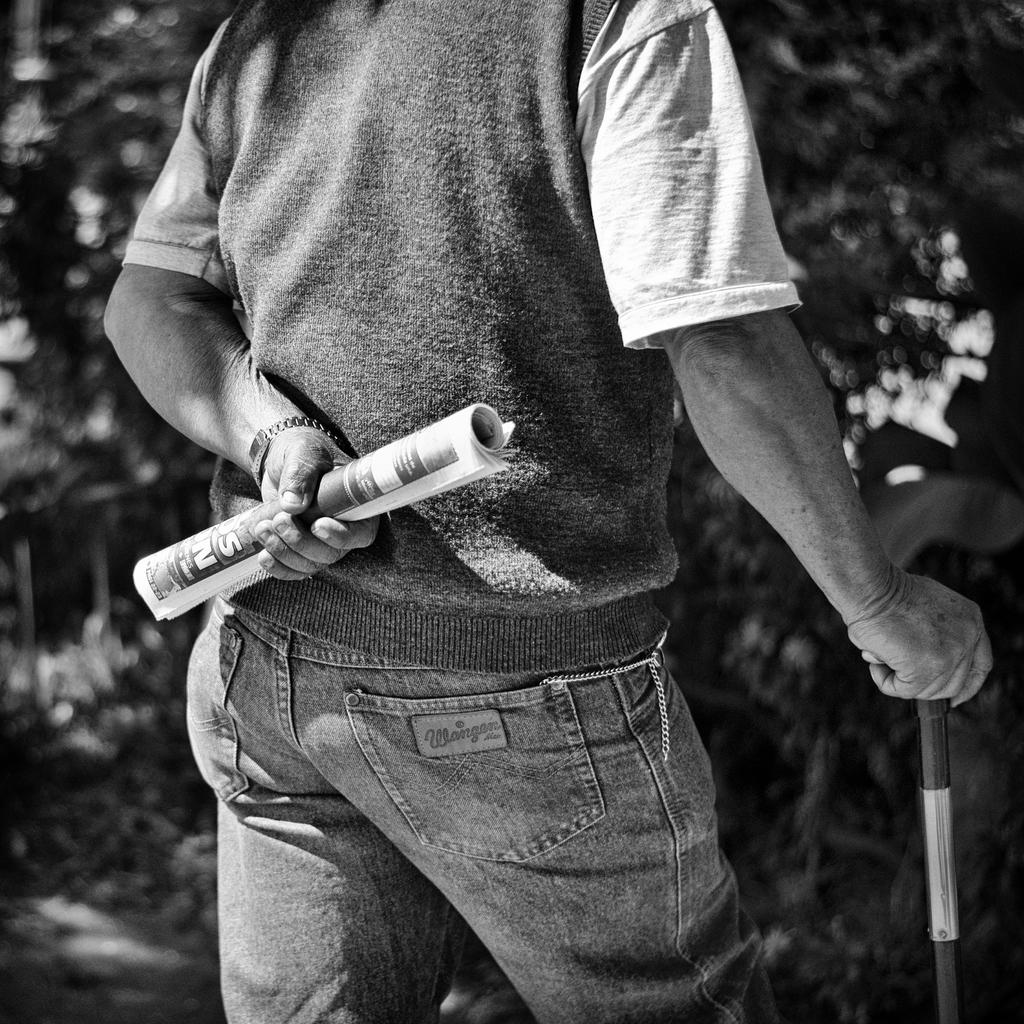What is the color scheme of the image? The image is black and white. Who is present in the image? There is a man in the image. What is the man holding in the image? The man is holding a newspaper and a walking stick. What can be seen in the background of the image? There are trees in the background of the image. What word is written on the skate in the image? There is no skate present in the image, so it is not possible to determine what word might be written on it. 